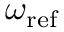Convert formula to latex. <formula><loc_0><loc_0><loc_500><loc_500>\omega _ { r e f }</formula> 